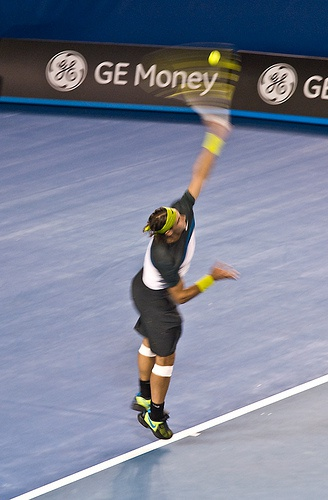Describe the objects in this image and their specific colors. I can see people in navy, black, darkgray, and white tones, tennis racket in navy, olive, black, and gray tones, and sports ball in navy, yellow, and olive tones in this image. 